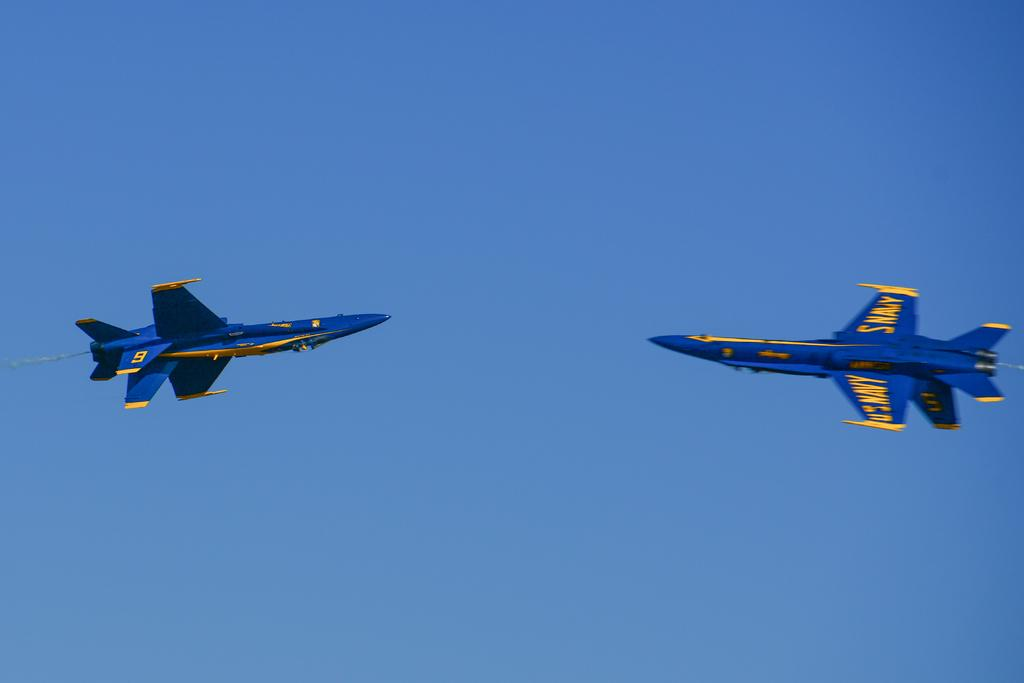What type of vehicles are in the image? There are two air fighters in the image. How are the air fighters positioned in relation to each other? The air fighters are facing each other. Where are the air fighters located in the image? The air fighters are flying in the sky. What type of bee can be seen flying alongside the air fighters in the image? There is no bee present in the image; it only features two air fighters flying in the sky. What type of drink is being served to the pilots in the image? There is no indication of any drink, such as eggnog, being served in the image. 